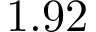<formula> <loc_0><loc_0><loc_500><loc_500>1 . 9 2</formula> 